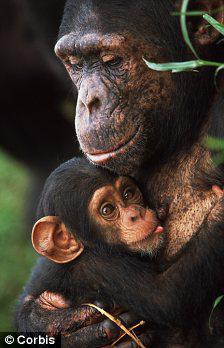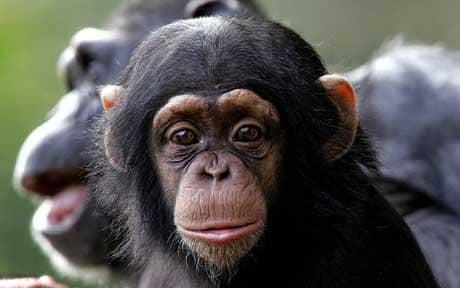The first image is the image on the left, the second image is the image on the right. Analyze the images presented: Is the assertion "In the left image, one chimp is baring its teeth." valid? Answer yes or no. No. The first image is the image on the left, the second image is the image on the right. Assess this claim about the two images: "There are two apes". Correct or not? Answer yes or no. No. The first image is the image on the left, the second image is the image on the right. Analyze the images presented: Is the assertion "In one of the images a baby monkey is cuddling its mother." valid? Answer yes or no. Yes. 